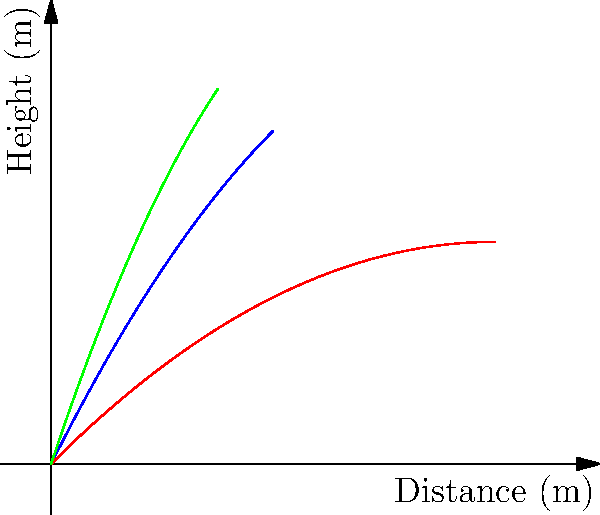Based on the trajectory diagrams of three different projectiles (A, B, and C), which projectile would likely have the highest impact force upon landing, assuming they all have the same mass? To determine which projectile would have the highest impact force, we need to consider the following factors:

1. Initial velocity: The steeper the initial angle of the trajectory, the higher the initial velocity.
2. Maximum height: A higher maximum height indicates more potential energy.
3. Range: The horizontal distance traveled before impact.
4. Impact angle: A steeper impact angle generally results in a higher impact force.

Analyzing each projectile:

A (Blue): 
- Moderate initial velocity
- Medium maximum height
- Medium range
- Moderate impact angle

B (Red):
- Lowest initial velocity
- Lowest maximum height
- Longest range
- Shallowest impact angle

C (Green):
- Highest initial velocity
- Highest maximum height
- Shortest range
- Steepest impact angle

Projectile C has the highest initial velocity and reaches the greatest height, which translates to more kinetic and potential energy. It also has the steepest impact angle, which means less energy is dissipated horizontally upon impact.

The impact force is directly related to the change in momentum over time ($$F = \frac{\Delta p}{\Delta t}$$). With its higher velocity and steeper impact angle, Projectile C will experience the greatest change in momentum in the shortest time, resulting in the highest impact force.
Answer: Projectile C 